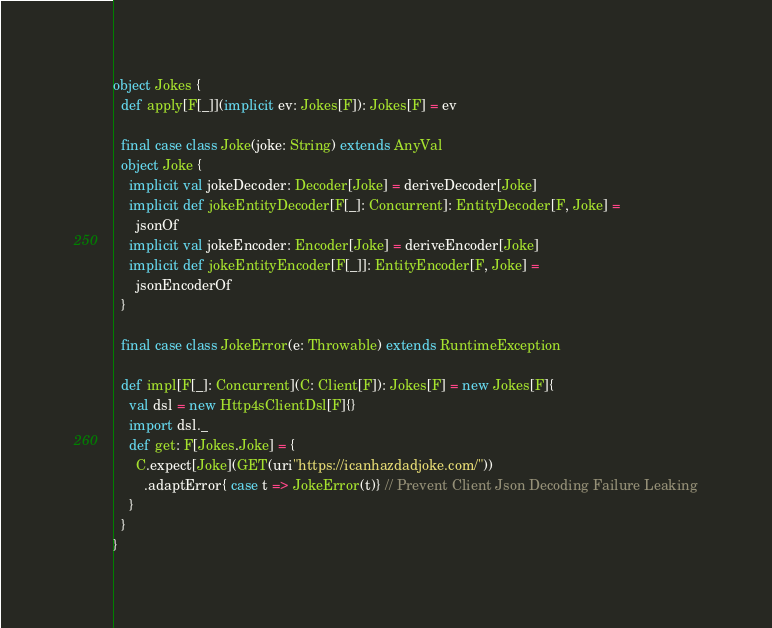Convert code to text. <code><loc_0><loc_0><loc_500><loc_500><_Scala_>
object Jokes {
  def apply[F[_]](implicit ev: Jokes[F]): Jokes[F] = ev

  final case class Joke(joke: String) extends AnyVal
  object Joke {
    implicit val jokeDecoder: Decoder[Joke] = deriveDecoder[Joke]
    implicit def jokeEntityDecoder[F[_]: Concurrent]: EntityDecoder[F, Joke] =
      jsonOf
    implicit val jokeEncoder: Encoder[Joke] = deriveEncoder[Joke]
    implicit def jokeEntityEncoder[F[_]]: EntityEncoder[F, Joke] =
      jsonEncoderOf
  }

  final case class JokeError(e: Throwable) extends RuntimeException

  def impl[F[_]: Concurrent](C: Client[F]): Jokes[F] = new Jokes[F]{
    val dsl = new Http4sClientDsl[F]{}
    import dsl._
    def get: F[Jokes.Joke] = {
      C.expect[Joke](GET(uri"https://icanhazdadjoke.com/"))
        .adaptError{ case t => JokeError(t)} // Prevent Client Json Decoding Failure Leaking
    }
  }
}
</code> 